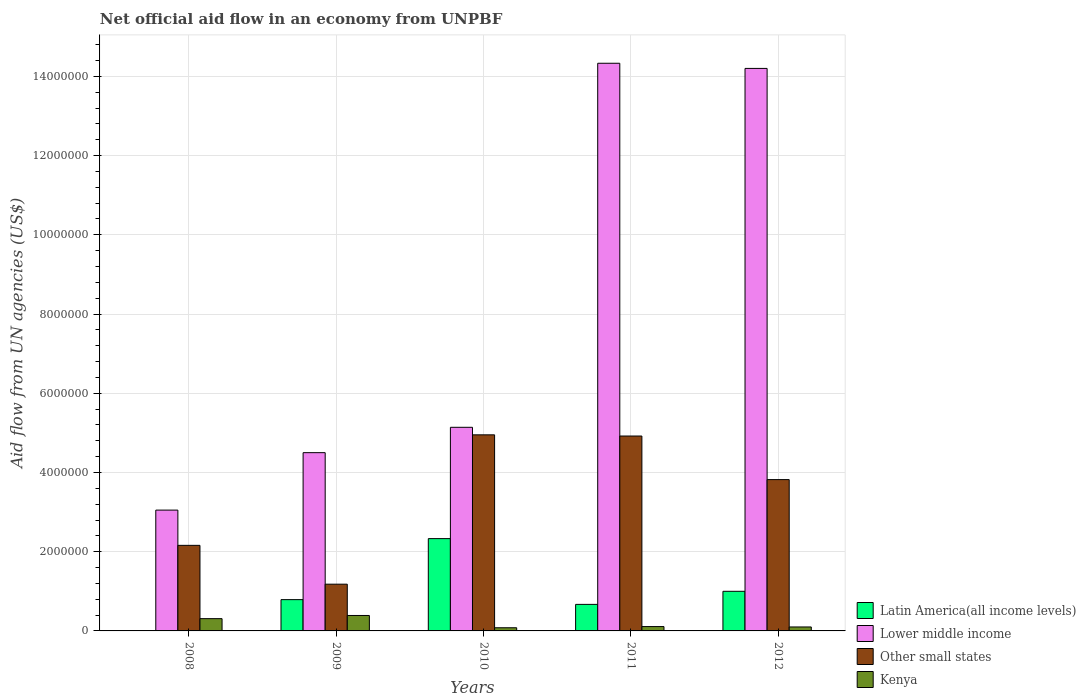How many different coloured bars are there?
Your response must be concise. 4. How many bars are there on the 4th tick from the right?
Keep it short and to the point. 4. What is the net official aid flow in Lower middle income in 2010?
Offer a terse response. 5.14e+06. Across all years, what is the maximum net official aid flow in Latin America(all income levels)?
Your answer should be compact. 2.33e+06. Across all years, what is the minimum net official aid flow in Lower middle income?
Give a very brief answer. 3.05e+06. What is the total net official aid flow in Lower middle income in the graph?
Keep it short and to the point. 4.12e+07. What is the difference between the net official aid flow in Other small states in 2009 and that in 2011?
Your answer should be very brief. -3.74e+06. What is the difference between the net official aid flow in Other small states in 2010 and the net official aid flow in Latin America(all income levels) in 2012?
Offer a very short reply. 3.95e+06. What is the average net official aid flow in Lower middle income per year?
Provide a succinct answer. 8.24e+06. In the year 2011, what is the difference between the net official aid flow in Latin America(all income levels) and net official aid flow in Kenya?
Your answer should be very brief. 5.60e+05. In how many years, is the net official aid flow in Kenya greater than 10800000 US$?
Ensure brevity in your answer.  0. Is the difference between the net official aid flow in Latin America(all income levels) in 2010 and 2012 greater than the difference between the net official aid flow in Kenya in 2010 and 2012?
Ensure brevity in your answer.  Yes. What is the difference between the highest and the second highest net official aid flow in Lower middle income?
Ensure brevity in your answer.  1.30e+05. What is the difference between the highest and the lowest net official aid flow in Kenya?
Your answer should be compact. 3.10e+05. Is it the case that in every year, the sum of the net official aid flow in Other small states and net official aid flow in Lower middle income is greater than the net official aid flow in Latin America(all income levels)?
Your answer should be compact. Yes. How many bars are there?
Give a very brief answer. 19. How many years are there in the graph?
Keep it short and to the point. 5. What is the difference between two consecutive major ticks on the Y-axis?
Provide a short and direct response. 2.00e+06. Does the graph contain any zero values?
Give a very brief answer. Yes. Does the graph contain grids?
Ensure brevity in your answer.  Yes. Where does the legend appear in the graph?
Provide a succinct answer. Bottom right. How are the legend labels stacked?
Your response must be concise. Vertical. What is the title of the graph?
Ensure brevity in your answer.  Net official aid flow in an economy from UNPBF. What is the label or title of the X-axis?
Your answer should be very brief. Years. What is the label or title of the Y-axis?
Keep it short and to the point. Aid flow from UN agencies (US$). What is the Aid flow from UN agencies (US$) in Latin America(all income levels) in 2008?
Provide a short and direct response. 0. What is the Aid flow from UN agencies (US$) in Lower middle income in 2008?
Keep it short and to the point. 3.05e+06. What is the Aid flow from UN agencies (US$) of Other small states in 2008?
Keep it short and to the point. 2.16e+06. What is the Aid flow from UN agencies (US$) in Kenya in 2008?
Provide a succinct answer. 3.10e+05. What is the Aid flow from UN agencies (US$) in Latin America(all income levels) in 2009?
Your response must be concise. 7.90e+05. What is the Aid flow from UN agencies (US$) in Lower middle income in 2009?
Offer a very short reply. 4.50e+06. What is the Aid flow from UN agencies (US$) in Other small states in 2009?
Make the answer very short. 1.18e+06. What is the Aid flow from UN agencies (US$) of Kenya in 2009?
Keep it short and to the point. 3.90e+05. What is the Aid flow from UN agencies (US$) of Latin America(all income levels) in 2010?
Make the answer very short. 2.33e+06. What is the Aid flow from UN agencies (US$) of Lower middle income in 2010?
Make the answer very short. 5.14e+06. What is the Aid flow from UN agencies (US$) in Other small states in 2010?
Provide a succinct answer. 4.95e+06. What is the Aid flow from UN agencies (US$) of Kenya in 2010?
Give a very brief answer. 8.00e+04. What is the Aid flow from UN agencies (US$) in Latin America(all income levels) in 2011?
Keep it short and to the point. 6.70e+05. What is the Aid flow from UN agencies (US$) of Lower middle income in 2011?
Keep it short and to the point. 1.43e+07. What is the Aid flow from UN agencies (US$) in Other small states in 2011?
Make the answer very short. 4.92e+06. What is the Aid flow from UN agencies (US$) in Latin America(all income levels) in 2012?
Provide a short and direct response. 1.00e+06. What is the Aid flow from UN agencies (US$) in Lower middle income in 2012?
Offer a terse response. 1.42e+07. What is the Aid flow from UN agencies (US$) in Other small states in 2012?
Your answer should be compact. 3.82e+06. Across all years, what is the maximum Aid flow from UN agencies (US$) in Latin America(all income levels)?
Your answer should be compact. 2.33e+06. Across all years, what is the maximum Aid flow from UN agencies (US$) of Lower middle income?
Give a very brief answer. 1.43e+07. Across all years, what is the maximum Aid flow from UN agencies (US$) of Other small states?
Your response must be concise. 4.95e+06. Across all years, what is the maximum Aid flow from UN agencies (US$) in Kenya?
Offer a very short reply. 3.90e+05. Across all years, what is the minimum Aid flow from UN agencies (US$) in Lower middle income?
Offer a very short reply. 3.05e+06. Across all years, what is the minimum Aid flow from UN agencies (US$) of Other small states?
Your answer should be very brief. 1.18e+06. What is the total Aid flow from UN agencies (US$) in Latin America(all income levels) in the graph?
Give a very brief answer. 4.79e+06. What is the total Aid flow from UN agencies (US$) in Lower middle income in the graph?
Offer a very short reply. 4.12e+07. What is the total Aid flow from UN agencies (US$) in Other small states in the graph?
Offer a terse response. 1.70e+07. What is the total Aid flow from UN agencies (US$) in Kenya in the graph?
Give a very brief answer. 9.90e+05. What is the difference between the Aid flow from UN agencies (US$) in Lower middle income in 2008 and that in 2009?
Your answer should be very brief. -1.45e+06. What is the difference between the Aid flow from UN agencies (US$) in Other small states in 2008 and that in 2009?
Your answer should be very brief. 9.80e+05. What is the difference between the Aid flow from UN agencies (US$) of Kenya in 2008 and that in 2009?
Your response must be concise. -8.00e+04. What is the difference between the Aid flow from UN agencies (US$) of Lower middle income in 2008 and that in 2010?
Provide a short and direct response. -2.09e+06. What is the difference between the Aid flow from UN agencies (US$) in Other small states in 2008 and that in 2010?
Your answer should be compact. -2.79e+06. What is the difference between the Aid flow from UN agencies (US$) in Lower middle income in 2008 and that in 2011?
Your response must be concise. -1.13e+07. What is the difference between the Aid flow from UN agencies (US$) of Other small states in 2008 and that in 2011?
Ensure brevity in your answer.  -2.76e+06. What is the difference between the Aid flow from UN agencies (US$) of Kenya in 2008 and that in 2011?
Offer a very short reply. 2.00e+05. What is the difference between the Aid flow from UN agencies (US$) in Lower middle income in 2008 and that in 2012?
Make the answer very short. -1.12e+07. What is the difference between the Aid flow from UN agencies (US$) of Other small states in 2008 and that in 2012?
Ensure brevity in your answer.  -1.66e+06. What is the difference between the Aid flow from UN agencies (US$) in Latin America(all income levels) in 2009 and that in 2010?
Ensure brevity in your answer.  -1.54e+06. What is the difference between the Aid flow from UN agencies (US$) of Lower middle income in 2009 and that in 2010?
Your answer should be very brief. -6.40e+05. What is the difference between the Aid flow from UN agencies (US$) in Other small states in 2009 and that in 2010?
Provide a short and direct response. -3.77e+06. What is the difference between the Aid flow from UN agencies (US$) in Kenya in 2009 and that in 2010?
Make the answer very short. 3.10e+05. What is the difference between the Aid flow from UN agencies (US$) in Latin America(all income levels) in 2009 and that in 2011?
Your response must be concise. 1.20e+05. What is the difference between the Aid flow from UN agencies (US$) in Lower middle income in 2009 and that in 2011?
Offer a very short reply. -9.83e+06. What is the difference between the Aid flow from UN agencies (US$) of Other small states in 2009 and that in 2011?
Offer a very short reply. -3.74e+06. What is the difference between the Aid flow from UN agencies (US$) of Kenya in 2009 and that in 2011?
Give a very brief answer. 2.80e+05. What is the difference between the Aid flow from UN agencies (US$) in Latin America(all income levels) in 2009 and that in 2012?
Offer a terse response. -2.10e+05. What is the difference between the Aid flow from UN agencies (US$) in Lower middle income in 2009 and that in 2012?
Provide a short and direct response. -9.70e+06. What is the difference between the Aid flow from UN agencies (US$) in Other small states in 2009 and that in 2012?
Your answer should be very brief. -2.64e+06. What is the difference between the Aid flow from UN agencies (US$) in Kenya in 2009 and that in 2012?
Your answer should be compact. 2.90e+05. What is the difference between the Aid flow from UN agencies (US$) of Latin America(all income levels) in 2010 and that in 2011?
Your answer should be very brief. 1.66e+06. What is the difference between the Aid flow from UN agencies (US$) in Lower middle income in 2010 and that in 2011?
Give a very brief answer. -9.19e+06. What is the difference between the Aid flow from UN agencies (US$) of Kenya in 2010 and that in 2011?
Ensure brevity in your answer.  -3.00e+04. What is the difference between the Aid flow from UN agencies (US$) of Latin America(all income levels) in 2010 and that in 2012?
Provide a short and direct response. 1.33e+06. What is the difference between the Aid flow from UN agencies (US$) of Lower middle income in 2010 and that in 2012?
Ensure brevity in your answer.  -9.06e+06. What is the difference between the Aid flow from UN agencies (US$) in Other small states in 2010 and that in 2012?
Provide a short and direct response. 1.13e+06. What is the difference between the Aid flow from UN agencies (US$) in Latin America(all income levels) in 2011 and that in 2012?
Provide a succinct answer. -3.30e+05. What is the difference between the Aid flow from UN agencies (US$) of Other small states in 2011 and that in 2012?
Offer a terse response. 1.10e+06. What is the difference between the Aid flow from UN agencies (US$) of Kenya in 2011 and that in 2012?
Ensure brevity in your answer.  10000. What is the difference between the Aid flow from UN agencies (US$) in Lower middle income in 2008 and the Aid flow from UN agencies (US$) in Other small states in 2009?
Offer a very short reply. 1.87e+06. What is the difference between the Aid flow from UN agencies (US$) of Lower middle income in 2008 and the Aid flow from UN agencies (US$) of Kenya in 2009?
Provide a short and direct response. 2.66e+06. What is the difference between the Aid flow from UN agencies (US$) of Other small states in 2008 and the Aid flow from UN agencies (US$) of Kenya in 2009?
Ensure brevity in your answer.  1.77e+06. What is the difference between the Aid flow from UN agencies (US$) of Lower middle income in 2008 and the Aid flow from UN agencies (US$) of Other small states in 2010?
Provide a succinct answer. -1.90e+06. What is the difference between the Aid flow from UN agencies (US$) of Lower middle income in 2008 and the Aid flow from UN agencies (US$) of Kenya in 2010?
Keep it short and to the point. 2.97e+06. What is the difference between the Aid flow from UN agencies (US$) in Other small states in 2008 and the Aid flow from UN agencies (US$) in Kenya in 2010?
Keep it short and to the point. 2.08e+06. What is the difference between the Aid flow from UN agencies (US$) in Lower middle income in 2008 and the Aid flow from UN agencies (US$) in Other small states in 2011?
Provide a succinct answer. -1.87e+06. What is the difference between the Aid flow from UN agencies (US$) of Lower middle income in 2008 and the Aid flow from UN agencies (US$) of Kenya in 2011?
Keep it short and to the point. 2.94e+06. What is the difference between the Aid flow from UN agencies (US$) in Other small states in 2008 and the Aid flow from UN agencies (US$) in Kenya in 2011?
Provide a succinct answer. 2.05e+06. What is the difference between the Aid flow from UN agencies (US$) of Lower middle income in 2008 and the Aid flow from UN agencies (US$) of Other small states in 2012?
Offer a terse response. -7.70e+05. What is the difference between the Aid flow from UN agencies (US$) of Lower middle income in 2008 and the Aid flow from UN agencies (US$) of Kenya in 2012?
Provide a short and direct response. 2.95e+06. What is the difference between the Aid flow from UN agencies (US$) in Other small states in 2008 and the Aid flow from UN agencies (US$) in Kenya in 2012?
Make the answer very short. 2.06e+06. What is the difference between the Aid flow from UN agencies (US$) in Latin America(all income levels) in 2009 and the Aid flow from UN agencies (US$) in Lower middle income in 2010?
Your answer should be compact. -4.35e+06. What is the difference between the Aid flow from UN agencies (US$) in Latin America(all income levels) in 2009 and the Aid flow from UN agencies (US$) in Other small states in 2010?
Ensure brevity in your answer.  -4.16e+06. What is the difference between the Aid flow from UN agencies (US$) in Latin America(all income levels) in 2009 and the Aid flow from UN agencies (US$) in Kenya in 2010?
Your answer should be compact. 7.10e+05. What is the difference between the Aid flow from UN agencies (US$) of Lower middle income in 2009 and the Aid flow from UN agencies (US$) of Other small states in 2010?
Your answer should be compact. -4.50e+05. What is the difference between the Aid flow from UN agencies (US$) of Lower middle income in 2009 and the Aid flow from UN agencies (US$) of Kenya in 2010?
Ensure brevity in your answer.  4.42e+06. What is the difference between the Aid flow from UN agencies (US$) of Other small states in 2009 and the Aid flow from UN agencies (US$) of Kenya in 2010?
Your answer should be compact. 1.10e+06. What is the difference between the Aid flow from UN agencies (US$) of Latin America(all income levels) in 2009 and the Aid flow from UN agencies (US$) of Lower middle income in 2011?
Your answer should be very brief. -1.35e+07. What is the difference between the Aid flow from UN agencies (US$) of Latin America(all income levels) in 2009 and the Aid flow from UN agencies (US$) of Other small states in 2011?
Keep it short and to the point. -4.13e+06. What is the difference between the Aid flow from UN agencies (US$) in Latin America(all income levels) in 2009 and the Aid flow from UN agencies (US$) in Kenya in 2011?
Provide a succinct answer. 6.80e+05. What is the difference between the Aid flow from UN agencies (US$) of Lower middle income in 2009 and the Aid flow from UN agencies (US$) of Other small states in 2011?
Provide a succinct answer. -4.20e+05. What is the difference between the Aid flow from UN agencies (US$) of Lower middle income in 2009 and the Aid flow from UN agencies (US$) of Kenya in 2011?
Provide a short and direct response. 4.39e+06. What is the difference between the Aid flow from UN agencies (US$) in Other small states in 2009 and the Aid flow from UN agencies (US$) in Kenya in 2011?
Keep it short and to the point. 1.07e+06. What is the difference between the Aid flow from UN agencies (US$) of Latin America(all income levels) in 2009 and the Aid flow from UN agencies (US$) of Lower middle income in 2012?
Offer a terse response. -1.34e+07. What is the difference between the Aid flow from UN agencies (US$) of Latin America(all income levels) in 2009 and the Aid flow from UN agencies (US$) of Other small states in 2012?
Your answer should be very brief. -3.03e+06. What is the difference between the Aid flow from UN agencies (US$) in Latin America(all income levels) in 2009 and the Aid flow from UN agencies (US$) in Kenya in 2012?
Keep it short and to the point. 6.90e+05. What is the difference between the Aid flow from UN agencies (US$) in Lower middle income in 2009 and the Aid flow from UN agencies (US$) in Other small states in 2012?
Offer a terse response. 6.80e+05. What is the difference between the Aid flow from UN agencies (US$) in Lower middle income in 2009 and the Aid flow from UN agencies (US$) in Kenya in 2012?
Your answer should be very brief. 4.40e+06. What is the difference between the Aid flow from UN agencies (US$) of Other small states in 2009 and the Aid flow from UN agencies (US$) of Kenya in 2012?
Make the answer very short. 1.08e+06. What is the difference between the Aid flow from UN agencies (US$) of Latin America(all income levels) in 2010 and the Aid flow from UN agencies (US$) of Lower middle income in 2011?
Give a very brief answer. -1.20e+07. What is the difference between the Aid flow from UN agencies (US$) of Latin America(all income levels) in 2010 and the Aid flow from UN agencies (US$) of Other small states in 2011?
Offer a very short reply. -2.59e+06. What is the difference between the Aid flow from UN agencies (US$) in Latin America(all income levels) in 2010 and the Aid flow from UN agencies (US$) in Kenya in 2011?
Your response must be concise. 2.22e+06. What is the difference between the Aid flow from UN agencies (US$) of Lower middle income in 2010 and the Aid flow from UN agencies (US$) of Other small states in 2011?
Provide a short and direct response. 2.20e+05. What is the difference between the Aid flow from UN agencies (US$) of Lower middle income in 2010 and the Aid flow from UN agencies (US$) of Kenya in 2011?
Provide a short and direct response. 5.03e+06. What is the difference between the Aid flow from UN agencies (US$) of Other small states in 2010 and the Aid flow from UN agencies (US$) of Kenya in 2011?
Provide a succinct answer. 4.84e+06. What is the difference between the Aid flow from UN agencies (US$) in Latin America(all income levels) in 2010 and the Aid flow from UN agencies (US$) in Lower middle income in 2012?
Provide a short and direct response. -1.19e+07. What is the difference between the Aid flow from UN agencies (US$) in Latin America(all income levels) in 2010 and the Aid flow from UN agencies (US$) in Other small states in 2012?
Your response must be concise. -1.49e+06. What is the difference between the Aid flow from UN agencies (US$) in Latin America(all income levels) in 2010 and the Aid flow from UN agencies (US$) in Kenya in 2012?
Offer a very short reply. 2.23e+06. What is the difference between the Aid flow from UN agencies (US$) in Lower middle income in 2010 and the Aid flow from UN agencies (US$) in Other small states in 2012?
Your answer should be compact. 1.32e+06. What is the difference between the Aid flow from UN agencies (US$) in Lower middle income in 2010 and the Aid flow from UN agencies (US$) in Kenya in 2012?
Provide a succinct answer. 5.04e+06. What is the difference between the Aid flow from UN agencies (US$) of Other small states in 2010 and the Aid flow from UN agencies (US$) of Kenya in 2012?
Your answer should be very brief. 4.85e+06. What is the difference between the Aid flow from UN agencies (US$) in Latin America(all income levels) in 2011 and the Aid flow from UN agencies (US$) in Lower middle income in 2012?
Keep it short and to the point. -1.35e+07. What is the difference between the Aid flow from UN agencies (US$) in Latin America(all income levels) in 2011 and the Aid flow from UN agencies (US$) in Other small states in 2012?
Keep it short and to the point. -3.15e+06. What is the difference between the Aid flow from UN agencies (US$) in Latin America(all income levels) in 2011 and the Aid flow from UN agencies (US$) in Kenya in 2012?
Your answer should be very brief. 5.70e+05. What is the difference between the Aid flow from UN agencies (US$) in Lower middle income in 2011 and the Aid flow from UN agencies (US$) in Other small states in 2012?
Make the answer very short. 1.05e+07. What is the difference between the Aid flow from UN agencies (US$) in Lower middle income in 2011 and the Aid flow from UN agencies (US$) in Kenya in 2012?
Ensure brevity in your answer.  1.42e+07. What is the difference between the Aid flow from UN agencies (US$) of Other small states in 2011 and the Aid flow from UN agencies (US$) of Kenya in 2012?
Offer a very short reply. 4.82e+06. What is the average Aid flow from UN agencies (US$) of Latin America(all income levels) per year?
Your answer should be very brief. 9.58e+05. What is the average Aid flow from UN agencies (US$) of Lower middle income per year?
Make the answer very short. 8.24e+06. What is the average Aid flow from UN agencies (US$) in Other small states per year?
Ensure brevity in your answer.  3.41e+06. What is the average Aid flow from UN agencies (US$) of Kenya per year?
Your answer should be compact. 1.98e+05. In the year 2008, what is the difference between the Aid flow from UN agencies (US$) of Lower middle income and Aid flow from UN agencies (US$) of Other small states?
Your answer should be compact. 8.90e+05. In the year 2008, what is the difference between the Aid flow from UN agencies (US$) in Lower middle income and Aid flow from UN agencies (US$) in Kenya?
Provide a succinct answer. 2.74e+06. In the year 2008, what is the difference between the Aid flow from UN agencies (US$) in Other small states and Aid flow from UN agencies (US$) in Kenya?
Keep it short and to the point. 1.85e+06. In the year 2009, what is the difference between the Aid flow from UN agencies (US$) of Latin America(all income levels) and Aid flow from UN agencies (US$) of Lower middle income?
Make the answer very short. -3.71e+06. In the year 2009, what is the difference between the Aid flow from UN agencies (US$) of Latin America(all income levels) and Aid flow from UN agencies (US$) of Other small states?
Provide a succinct answer. -3.90e+05. In the year 2009, what is the difference between the Aid flow from UN agencies (US$) in Latin America(all income levels) and Aid flow from UN agencies (US$) in Kenya?
Offer a terse response. 4.00e+05. In the year 2009, what is the difference between the Aid flow from UN agencies (US$) of Lower middle income and Aid flow from UN agencies (US$) of Other small states?
Offer a very short reply. 3.32e+06. In the year 2009, what is the difference between the Aid flow from UN agencies (US$) in Lower middle income and Aid flow from UN agencies (US$) in Kenya?
Your answer should be compact. 4.11e+06. In the year 2009, what is the difference between the Aid flow from UN agencies (US$) of Other small states and Aid flow from UN agencies (US$) of Kenya?
Offer a very short reply. 7.90e+05. In the year 2010, what is the difference between the Aid flow from UN agencies (US$) in Latin America(all income levels) and Aid flow from UN agencies (US$) in Lower middle income?
Keep it short and to the point. -2.81e+06. In the year 2010, what is the difference between the Aid flow from UN agencies (US$) of Latin America(all income levels) and Aid flow from UN agencies (US$) of Other small states?
Ensure brevity in your answer.  -2.62e+06. In the year 2010, what is the difference between the Aid flow from UN agencies (US$) of Latin America(all income levels) and Aid flow from UN agencies (US$) of Kenya?
Offer a terse response. 2.25e+06. In the year 2010, what is the difference between the Aid flow from UN agencies (US$) in Lower middle income and Aid flow from UN agencies (US$) in Other small states?
Give a very brief answer. 1.90e+05. In the year 2010, what is the difference between the Aid flow from UN agencies (US$) of Lower middle income and Aid flow from UN agencies (US$) of Kenya?
Your answer should be very brief. 5.06e+06. In the year 2010, what is the difference between the Aid flow from UN agencies (US$) in Other small states and Aid flow from UN agencies (US$) in Kenya?
Offer a terse response. 4.87e+06. In the year 2011, what is the difference between the Aid flow from UN agencies (US$) in Latin America(all income levels) and Aid flow from UN agencies (US$) in Lower middle income?
Your answer should be very brief. -1.37e+07. In the year 2011, what is the difference between the Aid flow from UN agencies (US$) of Latin America(all income levels) and Aid flow from UN agencies (US$) of Other small states?
Ensure brevity in your answer.  -4.25e+06. In the year 2011, what is the difference between the Aid flow from UN agencies (US$) in Latin America(all income levels) and Aid flow from UN agencies (US$) in Kenya?
Provide a short and direct response. 5.60e+05. In the year 2011, what is the difference between the Aid flow from UN agencies (US$) of Lower middle income and Aid flow from UN agencies (US$) of Other small states?
Give a very brief answer. 9.41e+06. In the year 2011, what is the difference between the Aid flow from UN agencies (US$) in Lower middle income and Aid flow from UN agencies (US$) in Kenya?
Offer a very short reply. 1.42e+07. In the year 2011, what is the difference between the Aid flow from UN agencies (US$) of Other small states and Aid flow from UN agencies (US$) of Kenya?
Make the answer very short. 4.81e+06. In the year 2012, what is the difference between the Aid flow from UN agencies (US$) of Latin America(all income levels) and Aid flow from UN agencies (US$) of Lower middle income?
Provide a succinct answer. -1.32e+07. In the year 2012, what is the difference between the Aid flow from UN agencies (US$) of Latin America(all income levels) and Aid flow from UN agencies (US$) of Other small states?
Offer a terse response. -2.82e+06. In the year 2012, what is the difference between the Aid flow from UN agencies (US$) of Lower middle income and Aid flow from UN agencies (US$) of Other small states?
Your answer should be compact. 1.04e+07. In the year 2012, what is the difference between the Aid flow from UN agencies (US$) of Lower middle income and Aid flow from UN agencies (US$) of Kenya?
Your answer should be very brief. 1.41e+07. In the year 2012, what is the difference between the Aid flow from UN agencies (US$) of Other small states and Aid flow from UN agencies (US$) of Kenya?
Give a very brief answer. 3.72e+06. What is the ratio of the Aid flow from UN agencies (US$) of Lower middle income in 2008 to that in 2009?
Your answer should be compact. 0.68. What is the ratio of the Aid flow from UN agencies (US$) in Other small states in 2008 to that in 2009?
Provide a short and direct response. 1.83. What is the ratio of the Aid flow from UN agencies (US$) of Kenya in 2008 to that in 2009?
Offer a terse response. 0.79. What is the ratio of the Aid flow from UN agencies (US$) in Lower middle income in 2008 to that in 2010?
Provide a short and direct response. 0.59. What is the ratio of the Aid flow from UN agencies (US$) of Other small states in 2008 to that in 2010?
Keep it short and to the point. 0.44. What is the ratio of the Aid flow from UN agencies (US$) in Kenya in 2008 to that in 2010?
Your answer should be very brief. 3.88. What is the ratio of the Aid flow from UN agencies (US$) of Lower middle income in 2008 to that in 2011?
Provide a short and direct response. 0.21. What is the ratio of the Aid flow from UN agencies (US$) in Other small states in 2008 to that in 2011?
Offer a very short reply. 0.44. What is the ratio of the Aid flow from UN agencies (US$) in Kenya in 2008 to that in 2011?
Ensure brevity in your answer.  2.82. What is the ratio of the Aid flow from UN agencies (US$) of Lower middle income in 2008 to that in 2012?
Provide a succinct answer. 0.21. What is the ratio of the Aid flow from UN agencies (US$) in Other small states in 2008 to that in 2012?
Your response must be concise. 0.57. What is the ratio of the Aid flow from UN agencies (US$) in Kenya in 2008 to that in 2012?
Your answer should be compact. 3.1. What is the ratio of the Aid flow from UN agencies (US$) in Latin America(all income levels) in 2009 to that in 2010?
Make the answer very short. 0.34. What is the ratio of the Aid flow from UN agencies (US$) of Lower middle income in 2009 to that in 2010?
Your response must be concise. 0.88. What is the ratio of the Aid flow from UN agencies (US$) in Other small states in 2009 to that in 2010?
Provide a short and direct response. 0.24. What is the ratio of the Aid flow from UN agencies (US$) of Kenya in 2009 to that in 2010?
Give a very brief answer. 4.88. What is the ratio of the Aid flow from UN agencies (US$) of Latin America(all income levels) in 2009 to that in 2011?
Offer a terse response. 1.18. What is the ratio of the Aid flow from UN agencies (US$) of Lower middle income in 2009 to that in 2011?
Your answer should be compact. 0.31. What is the ratio of the Aid flow from UN agencies (US$) of Other small states in 2009 to that in 2011?
Your answer should be compact. 0.24. What is the ratio of the Aid flow from UN agencies (US$) of Kenya in 2009 to that in 2011?
Offer a terse response. 3.55. What is the ratio of the Aid flow from UN agencies (US$) of Latin America(all income levels) in 2009 to that in 2012?
Offer a terse response. 0.79. What is the ratio of the Aid flow from UN agencies (US$) of Lower middle income in 2009 to that in 2012?
Offer a terse response. 0.32. What is the ratio of the Aid flow from UN agencies (US$) in Other small states in 2009 to that in 2012?
Offer a very short reply. 0.31. What is the ratio of the Aid flow from UN agencies (US$) in Kenya in 2009 to that in 2012?
Make the answer very short. 3.9. What is the ratio of the Aid flow from UN agencies (US$) in Latin America(all income levels) in 2010 to that in 2011?
Your response must be concise. 3.48. What is the ratio of the Aid flow from UN agencies (US$) in Lower middle income in 2010 to that in 2011?
Keep it short and to the point. 0.36. What is the ratio of the Aid flow from UN agencies (US$) in Other small states in 2010 to that in 2011?
Offer a very short reply. 1.01. What is the ratio of the Aid flow from UN agencies (US$) of Kenya in 2010 to that in 2011?
Your response must be concise. 0.73. What is the ratio of the Aid flow from UN agencies (US$) of Latin America(all income levels) in 2010 to that in 2012?
Provide a short and direct response. 2.33. What is the ratio of the Aid flow from UN agencies (US$) of Lower middle income in 2010 to that in 2012?
Make the answer very short. 0.36. What is the ratio of the Aid flow from UN agencies (US$) in Other small states in 2010 to that in 2012?
Your answer should be very brief. 1.3. What is the ratio of the Aid flow from UN agencies (US$) in Latin America(all income levels) in 2011 to that in 2012?
Provide a short and direct response. 0.67. What is the ratio of the Aid flow from UN agencies (US$) in Lower middle income in 2011 to that in 2012?
Provide a short and direct response. 1.01. What is the ratio of the Aid flow from UN agencies (US$) in Other small states in 2011 to that in 2012?
Give a very brief answer. 1.29. What is the difference between the highest and the second highest Aid flow from UN agencies (US$) in Latin America(all income levels)?
Provide a succinct answer. 1.33e+06. What is the difference between the highest and the second highest Aid flow from UN agencies (US$) of Kenya?
Your answer should be very brief. 8.00e+04. What is the difference between the highest and the lowest Aid flow from UN agencies (US$) in Latin America(all income levels)?
Your response must be concise. 2.33e+06. What is the difference between the highest and the lowest Aid flow from UN agencies (US$) in Lower middle income?
Provide a short and direct response. 1.13e+07. What is the difference between the highest and the lowest Aid flow from UN agencies (US$) of Other small states?
Your answer should be very brief. 3.77e+06. What is the difference between the highest and the lowest Aid flow from UN agencies (US$) of Kenya?
Ensure brevity in your answer.  3.10e+05. 